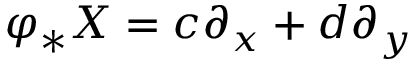<formula> <loc_0><loc_0><loc_500><loc_500>\varphi _ { * } X = c \partial _ { x } + d \partial _ { y }</formula> 